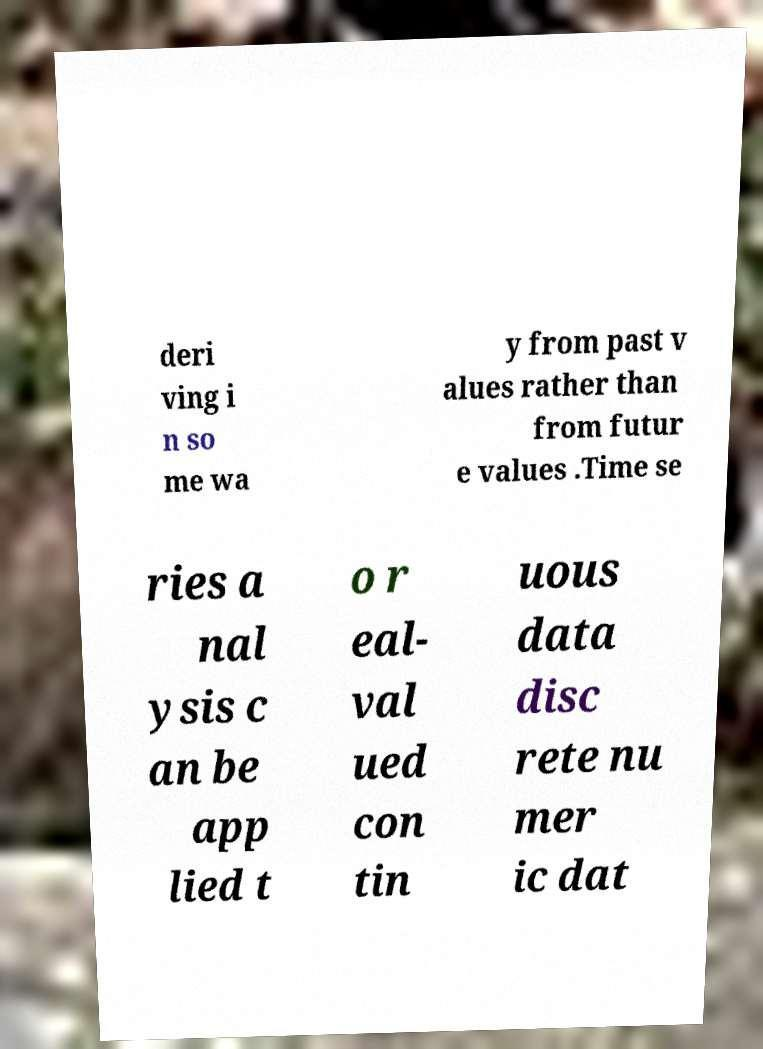What messages or text are displayed in this image? I need them in a readable, typed format. deri ving i n so me wa y from past v alues rather than from futur e values .Time se ries a nal ysis c an be app lied t o r eal- val ued con tin uous data disc rete nu mer ic dat 